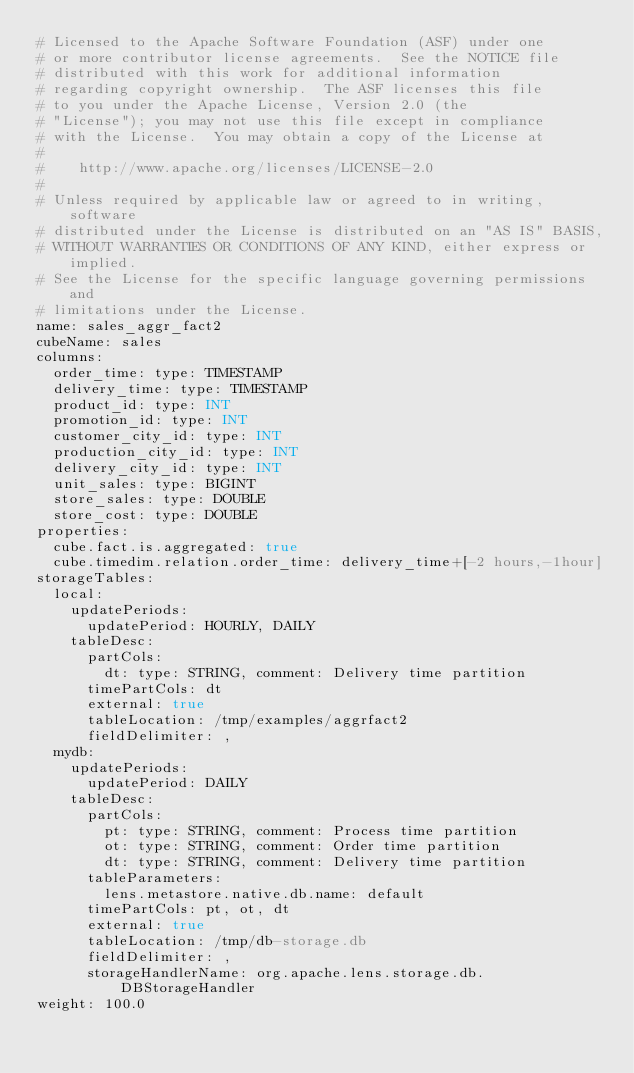Convert code to text. <code><loc_0><loc_0><loc_500><loc_500><_YAML_># Licensed to the Apache Software Foundation (ASF) under one
# or more contributor license agreements.  See the NOTICE file
# distributed with this work for additional information
# regarding copyright ownership.  The ASF licenses this file
# to you under the Apache License, Version 2.0 (the
# "License"); you may not use this file except in compliance
# with the License.  You may obtain a copy of the License at
#
#    http://www.apache.org/licenses/LICENSE-2.0
#
# Unless required by applicable law or agreed to in writing, software
# distributed under the License is distributed on an "AS IS" BASIS,
# WITHOUT WARRANTIES OR CONDITIONS OF ANY KIND, either express or implied.
# See the License for the specific language governing permissions and
# limitations under the License.
name: sales_aggr_fact2
cubeName: sales
columns:
  order_time: type: TIMESTAMP
  delivery_time: type: TIMESTAMP
  product_id: type: INT
  promotion_id: type: INT
  customer_city_id: type: INT
  production_city_id: type: INT
  delivery_city_id: type: INT
  unit_sales: type: BIGINT
  store_sales: type: DOUBLE
  store_cost: type: DOUBLE
properties:
  cube.fact.is.aggregated: true
  cube.timedim.relation.order_time: delivery_time+[-2 hours,-1hour]
storageTables:
  local:
    updatePeriods:
      updatePeriod: HOURLY, DAILY
    tableDesc:
      partCols:
        dt: type: STRING, comment: Delivery time partition
      timePartCols: dt
      external: true
      tableLocation: /tmp/examples/aggrfact2
      fieldDelimiter: ,
  mydb:
    updatePeriods:
      updatePeriod: DAILY
    tableDesc:
      partCols:
        pt: type: STRING, comment: Process time partition
        ot: type: STRING, comment: Order time partition
        dt: type: STRING, comment: Delivery time partition
      tableParameters:
        lens.metastore.native.db.name: default
      timePartCols: pt, ot, dt
      external: true
      tableLocation: /tmp/db-storage.db
      fieldDelimiter: ,
      storageHandlerName: org.apache.lens.storage.db.DBStorageHandler
weight: 100.0
</code> 